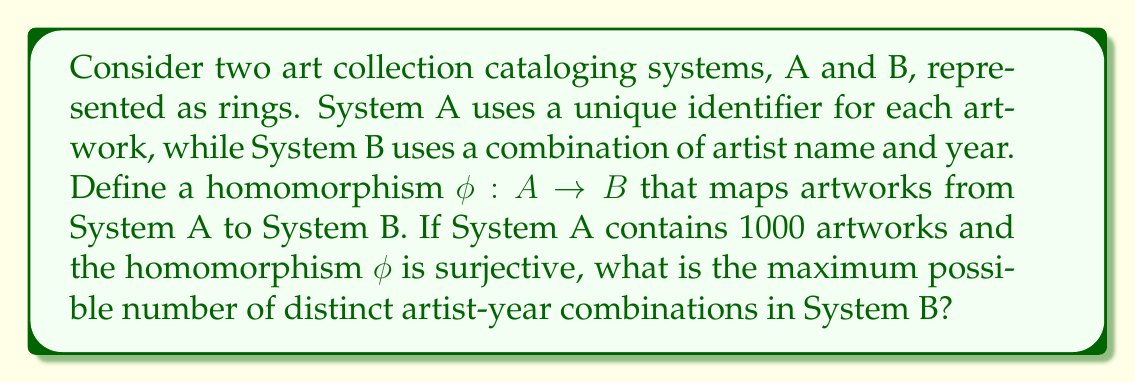Could you help me with this problem? To solve this problem, we need to understand the properties of ring homomorphisms and apply them to our art cataloging systems:

1) A ring homomorphism $\phi: A \to B$ is a function that preserves the ring structure, including addition and multiplication.

2) In this case, the homomorphism $\phi$ maps unique identifiers from System A to artist-year combinations in System B.

3) The homomorphism is given to be surjective, which means every element in the codomain (System B) is mapped to by at least one element in the domain (System A).

4) The First Isomorphism Theorem for rings states that for a surjective homomorphism $\phi: A \to B$, we have:

   $$A / \text{ker}(\phi) \cong B$$

   where $\text{ker}(\phi)$ is the kernel of $\phi$, and $\cong$ denotes ring isomorphism.

5) This implies that the size of B is equal to the size of A divided by the size of the kernel of $\phi$.

6) The maximum number of distinct elements in B occurs when the kernel is as small as possible. For a non-trivial ring homomorphism, the kernel must contain at least the zero element.

7) Therefore, the maximum size of B is achieved when $|\text{ker}(\phi)| = 1$, i.e., when $\phi$ is injective as well as surjective (bijective).

8) In this case, the maximum number of distinct artist-year combinations in System B would be equal to the number of artworks in System A, which is 1000.
Answer: The maximum possible number of distinct artist-year combinations in System B is 1000. 